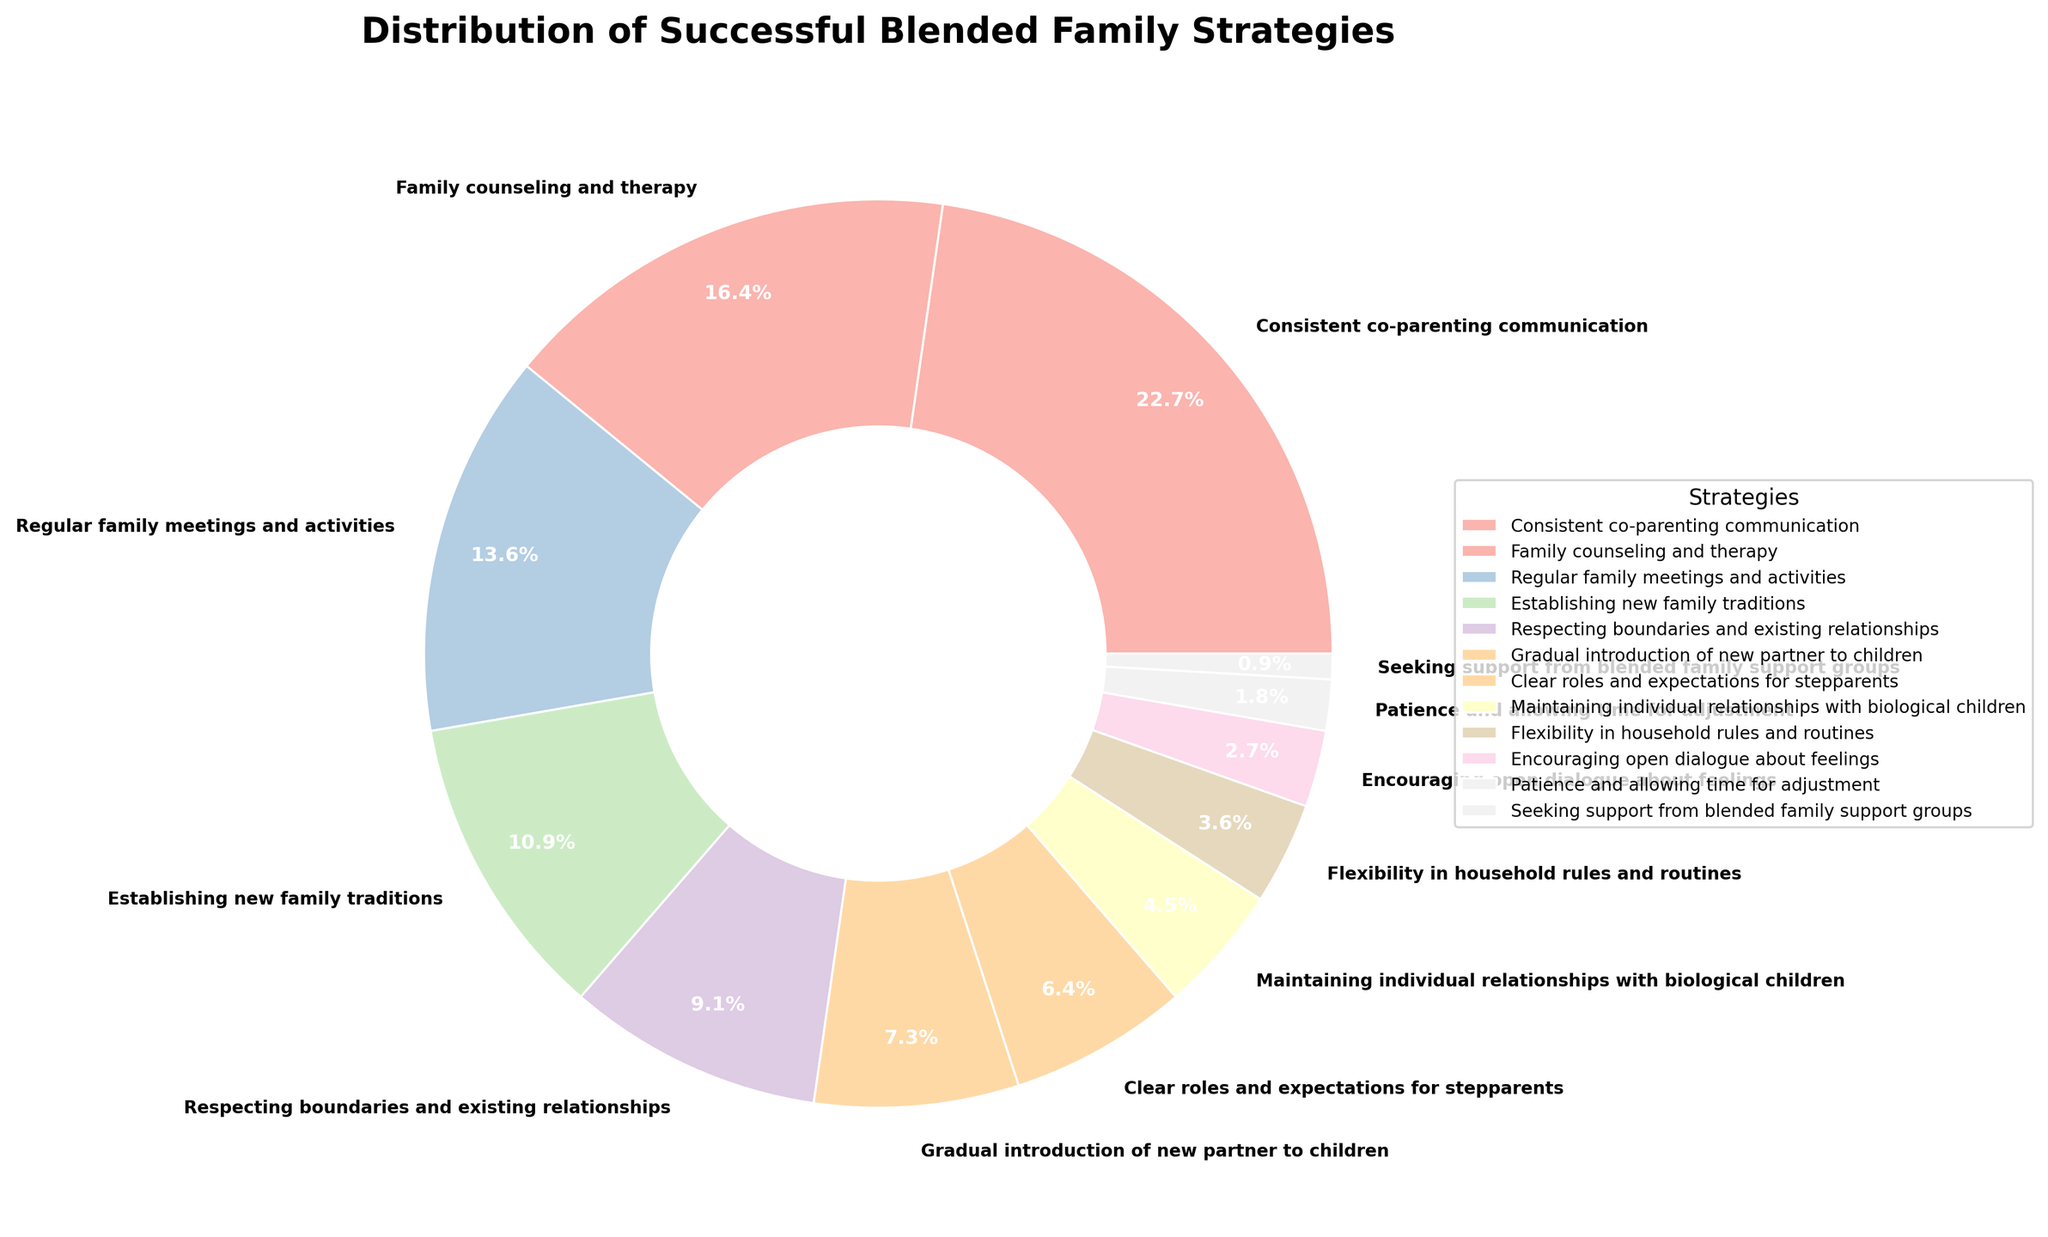Which strategy has the highest percentage? First, identify all the strategies. Then, compare their percentages to find the highest. "Consistent co-parenting communication" has the highest percentage at 25%.
Answer: Consistent co-parenting communication Which strategy has the lowest percentage? First, identify all the strategies. Then, compare their percentages to find the lowest. "Seeking support from blended family support groups" has the lowest percentage at 1%.
Answer: Seeking support from blended family support groups What is the combined percentage of "Family counseling and therapy" and "Regular family meetings and activities"? Find the percentage of "Family counseling and therapy" (18%) and "Regular family meetings and activities" (15%). Add them together: 18% + 15% = 33%.
Answer: 33% Is "Establishing new family traditions" more popular than "Respecting boundaries and existing relationships"? Compare the percentages of "Establishing new family traditions" (12%) and "Respecting boundaries and existing relationships" (10%). 12% is greater than 10%.
Answer: Yes What is the percentage difference between the most and least popular strategies? Find the most popular (25%) and the least popular (1%) strategies. Subtract the least from the most: 25% - 1% = 24%.
Answer: 24% How many strategies have a percentage greater than 10%? Identify all strategies and count those with percentages greater than 10%: "Consistent co-parenting communication" (25%), "Family counseling and therapy" (18%), "Regular family meetings and activities" (15%), and "Establishing new family traditions" (12%). There are 4 such strategies.
Answer: 4 Are "Patience and allowing time for adjustment" and "Seeking support from blended family support groups" together accounting for more than 3%? Add the percentages of both strategies: "Patience and allowing time for adjustment" (2%) + "Seeking support from blended family support groups" (1%) = 3%. They account exactly for 3%, not more.
Answer: No Which has a greater percentage: "Clear roles and expectations for stepparents" or "Maintaining individual relationships with biological children"? Compare "Clear roles and expectations for stepparents" (7%) and "Maintaining individual relationships with biological children" (5%). 7% is greater than 5%.
Answer: Clear roles and expectations for stepparents What is the average percentage of the four most popular strategies? Identify the four most popular strategies: 25%, 18%, 15%, 12%. Add them and divide by 4: (25% + 18% + 15% + 12%) / 4 = 17.5%.
Answer: 17.5% Which strategies together make up exactly 50% of the distribution? Find combinations of strategies to total 50%. "Consistent co-parenting communication" (25%), "Family counseling and therapy" (18%), and "Regular family meetings and activities" (15%) together make (25% + 18% + 15%) = 58%. "Family counseling and therapy" (18%), and "Regular family meetings and activities" (15%), and "Establishing new family traditions" (12%), and "Respecting boundaries and existing relationships" (10%) together make (18% + 15% + 12% + 5%) = 50%.
Answer: Family counseling and therapy, Regular family meetings and activities, Establishing new family traditions, Respecting boundaries and existing relationships 